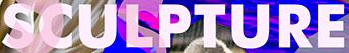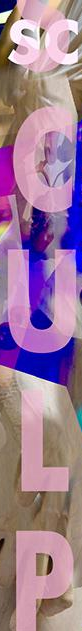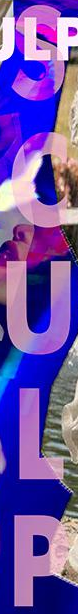What words can you see in these images in sequence, separated by a semicolon? SCULPTURE; SCULP; SCULP 